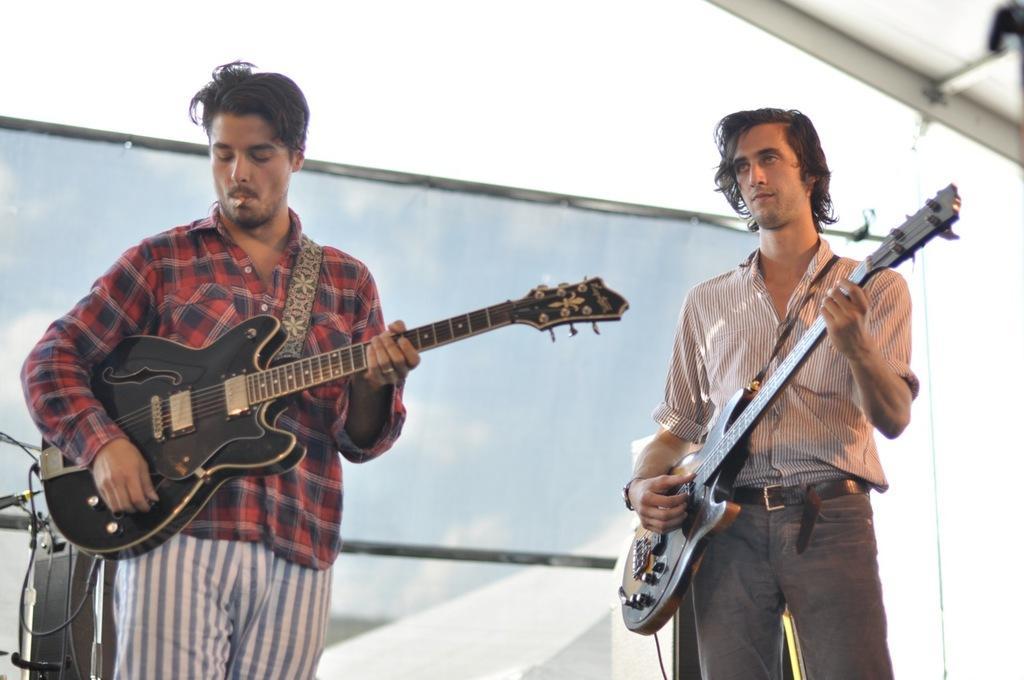Please provide a concise description of this image. In this picture we can see two people are playing guitar by holding in their hands, in the background we can see microphone and some musical stuff. 